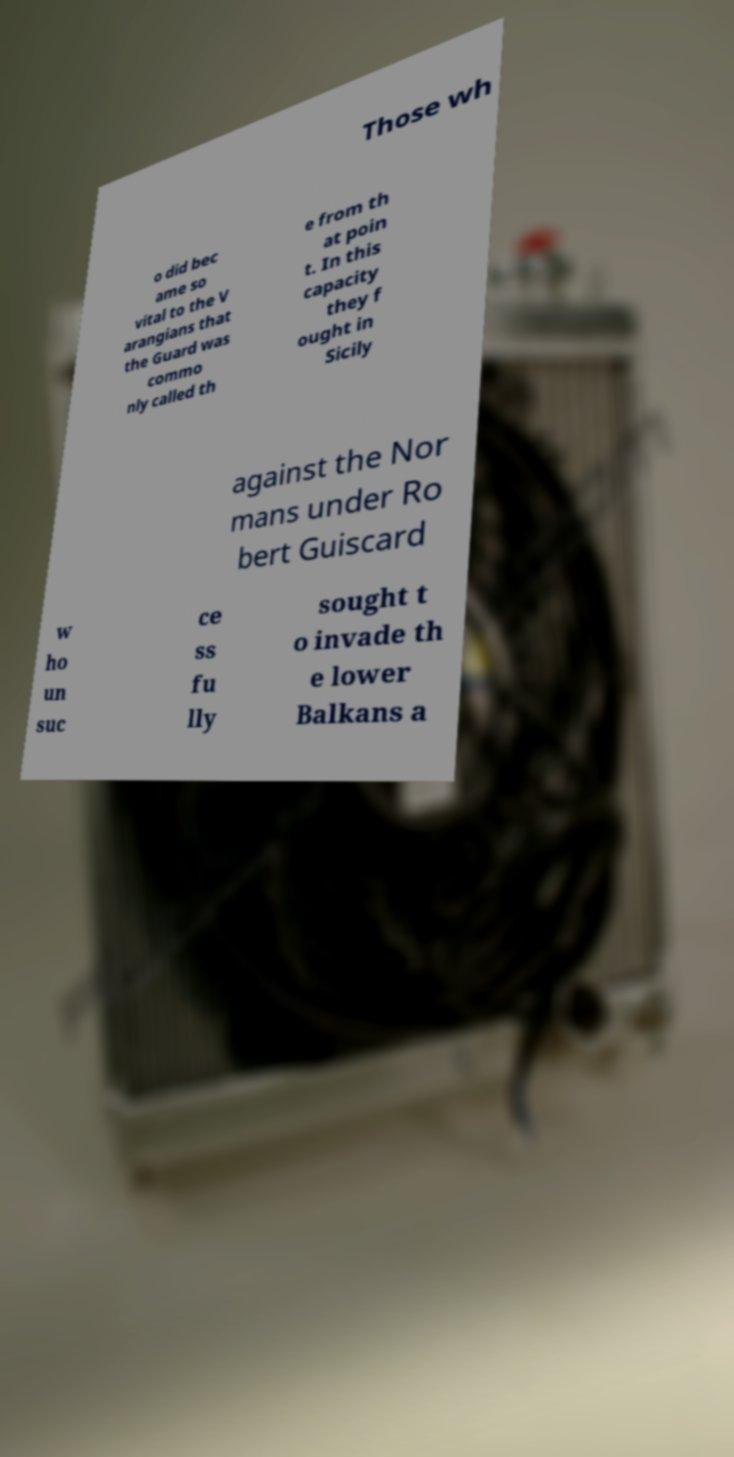Can you accurately transcribe the text from the provided image for me? Those wh o did bec ame so vital to the V arangians that the Guard was commo nly called th e from th at poin t. In this capacity they f ought in Sicily against the Nor mans under Ro bert Guiscard w ho un suc ce ss fu lly sought t o invade th e lower Balkans a 